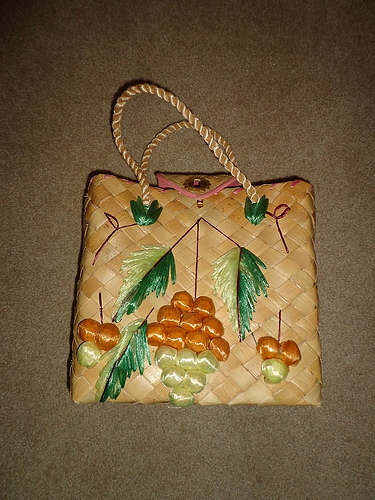<image>
Is there a bag on the floor? Yes. Looking at the image, I can see the bag is positioned on top of the floor, with the floor providing support. 